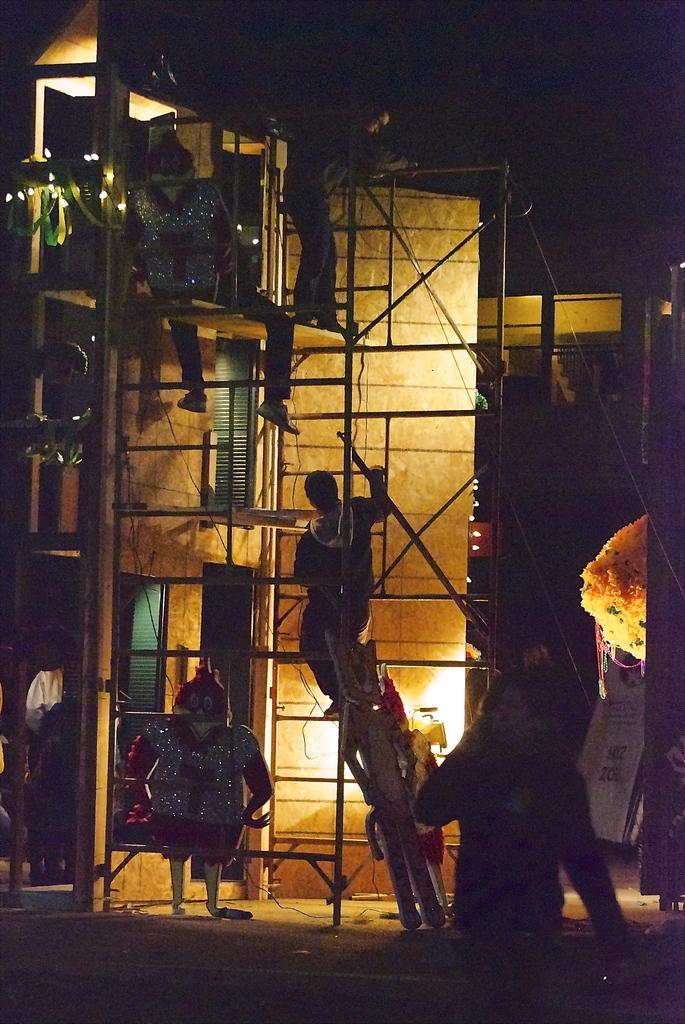Please provide a concise description of this image. In this image, we can see some people and we can see a building. 